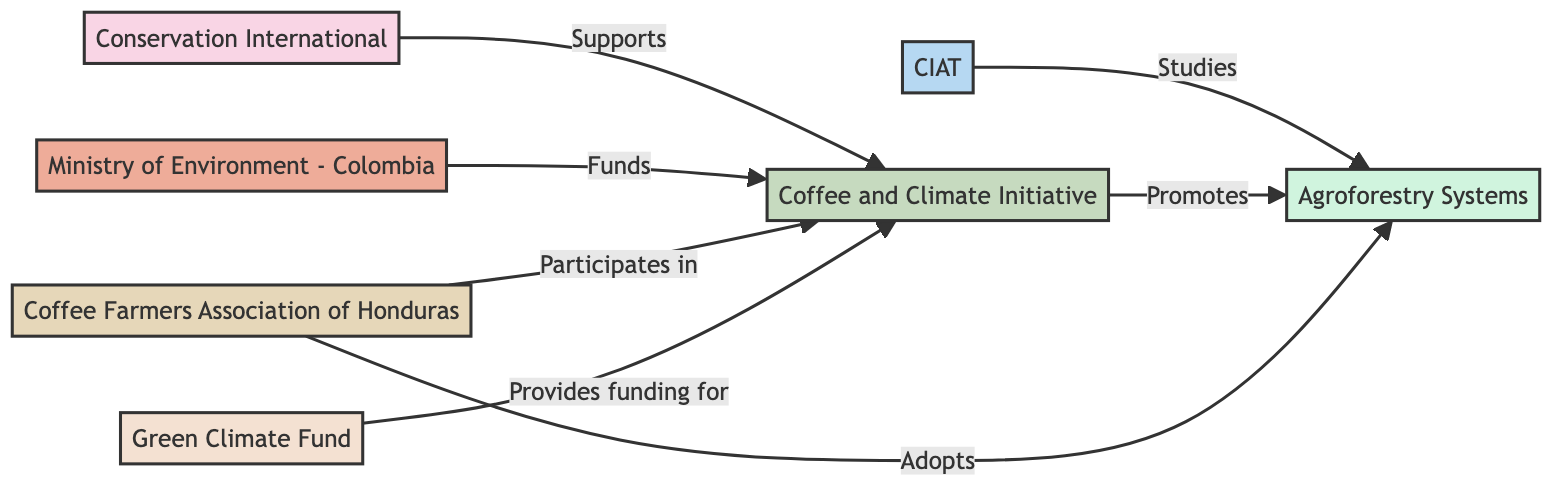What organization is identified as an NGO in the diagram? The diagram identifies "Conservation International" as the NGO, as it is labeled specifically under the "Organization" category.
Answer: Conservation International Who funds the biodiversity initiatives? The "Ministry of Environment - Colombia" is indicated as the funding body for the biodiversity initiatives, as shown by the directed edge labeled "Funds" pointing towards "BiodiversityInitiatives."
Answer: Ministry of Environment - Colombia How many local communities are represented in the diagram? The diagram lists one local community, which is "Coffee Farmers Association of Honduras," shown as a singular node without any other local community nodes.
Answer: 1 Which organization studies conservation practices? "CIAT (International Center for Tropical Agriculture)" is shown in the diagram as the research institution that studies conservation practices, indicated by the directed edge labeled "Studies."
Answer: CIAT (International Center for Tropical Agriculture) What does the Coffee and Climate Initiative promote? The directed edge from "BiodiversityInitiatives" to "ConservationPractices" labeled "Promotes" indicates that it promotes "Agroforestry Systems."
Answer: Agroforestry Systems How do local communities interact with biodiversity initiatives? The diagram shows that local communities "Participate in" the biodiversity initiatives, which is denoted by the edge coming from "LocalCommunities" to "BiodiversityInitiatives."
Answer: Participates in What type of funding does the Green Climate Fund provide? The diagram points out that the Green Climate Fund "Provides funding for" the biodiversity initiatives, establishing its role as a funding organization.
Answer: Provides funding for Which practices do local communities adopt? The directed edge leads from "LocalCommunities" to "ConservationPractices" with the label "Adopts," indicating that local communities adopt these practices.
Answer: ConservationPractices How many directed connections are there in the diagram? By counting the connections listed, which include the edges among different organizations, the total is seven.
Answer: 7 